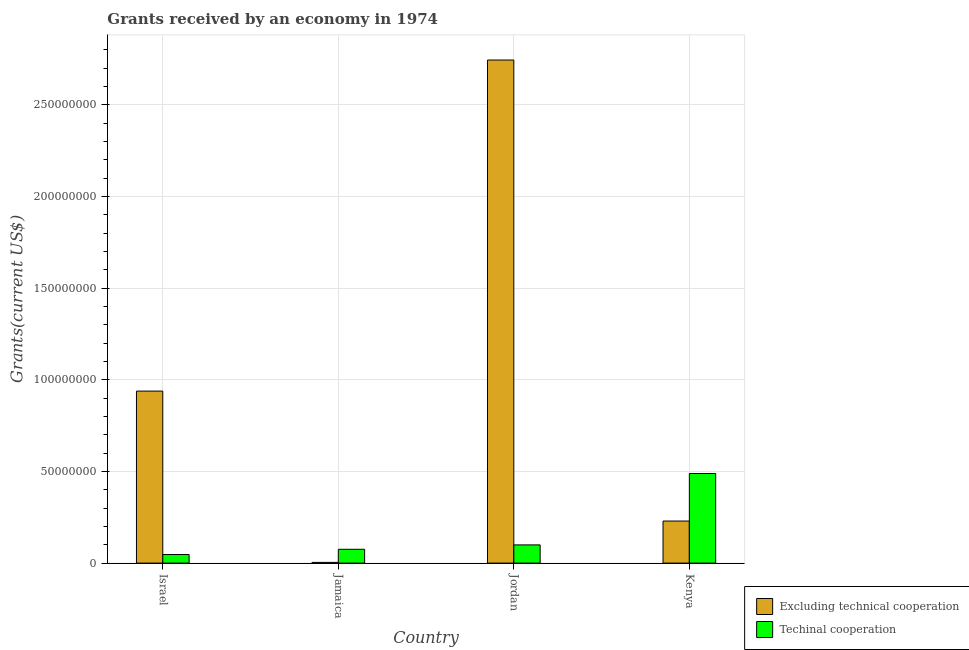How many different coloured bars are there?
Your answer should be compact. 2. How many groups of bars are there?
Your answer should be compact. 4. How many bars are there on the 3rd tick from the left?
Offer a terse response. 2. What is the label of the 2nd group of bars from the left?
Ensure brevity in your answer.  Jamaica. In how many cases, is the number of bars for a given country not equal to the number of legend labels?
Make the answer very short. 0. What is the amount of grants received(excluding technical cooperation) in Israel?
Your answer should be very brief. 9.38e+07. Across all countries, what is the maximum amount of grants received(excluding technical cooperation)?
Provide a succinct answer. 2.74e+08. Across all countries, what is the minimum amount of grants received(including technical cooperation)?
Make the answer very short. 4.68e+06. In which country was the amount of grants received(excluding technical cooperation) maximum?
Your answer should be compact. Jordan. What is the total amount of grants received(including technical cooperation) in the graph?
Your response must be concise. 7.10e+07. What is the difference between the amount of grants received(excluding technical cooperation) in Jamaica and that in Kenya?
Keep it short and to the point. -2.26e+07. What is the difference between the amount of grants received(including technical cooperation) in Israel and the amount of grants received(excluding technical cooperation) in Jordan?
Your answer should be compact. -2.70e+08. What is the average amount of grants received(including technical cooperation) per country?
Your answer should be very brief. 1.78e+07. What is the difference between the amount of grants received(excluding technical cooperation) and amount of grants received(including technical cooperation) in Jordan?
Make the answer very short. 2.64e+08. In how many countries, is the amount of grants received(excluding technical cooperation) greater than 30000000 US$?
Your answer should be compact. 2. What is the ratio of the amount of grants received(including technical cooperation) in Israel to that in Jordan?
Your response must be concise. 0.47. Is the difference between the amount of grants received(excluding technical cooperation) in Israel and Kenya greater than the difference between the amount of grants received(including technical cooperation) in Israel and Kenya?
Keep it short and to the point. Yes. What is the difference between the highest and the second highest amount of grants received(including technical cooperation)?
Your answer should be very brief. 3.90e+07. What is the difference between the highest and the lowest amount of grants received(excluding technical cooperation)?
Provide a short and direct response. 2.74e+08. In how many countries, is the amount of grants received(excluding technical cooperation) greater than the average amount of grants received(excluding technical cooperation) taken over all countries?
Ensure brevity in your answer.  1. Is the sum of the amount of grants received(excluding technical cooperation) in Israel and Kenya greater than the maximum amount of grants received(including technical cooperation) across all countries?
Provide a succinct answer. Yes. What does the 1st bar from the left in Jamaica represents?
Keep it short and to the point. Excluding technical cooperation. What does the 1st bar from the right in Kenya represents?
Offer a terse response. Techinal cooperation. Are all the bars in the graph horizontal?
Provide a succinct answer. No. How many countries are there in the graph?
Ensure brevity in your answer.  4. Are the values on the major ticks of Y-axis written in scientific E-notation?
Provide a short and direct response. No. Where does the legend appear in the graph?
Offer a terse response. Bottom right. How many legend labels are there?
Offer a terse response. 2. How are the legend labels stacked?
Ensure brevity in your answer.  Vertical. What is the title of the graph?
Make the answer very short. Grants received by an economy in 1974. What is the label or title of the Y-axis?
Offer a terse response. Grants(current US$). What is the Grants(current US$) in Excluding technical cooperation in Israel?
Offer a very short reply. 9.38e+07. What is the Grants(current US$) of Techinal cooperation in Israel?
Ensure brevity in your answer.  4.68e+06. What is the Grants(current US$) of Excluding technical cooperation in Jamaica?
Provide a short and direct response. 3.80e+05. What is the Grants(current US$) in Techinal cooperation in Jamaica?
Ensure brevity in your answer.  7.53e+06. What is the Grants(current US$) in Excluding technical cooperation in Jordan?
Provide a succinct answer. 2.74e+08. What is the Grants(current US$) in Techinal cooperation in Jordan?
Ensure brevity in your answer.  9.93e+06. What is the Grants(current US$) in Excluding technical cooperation in Kenya?
Ensure brevity in your answer.  2.29e+07. What is the Grants(current US$) of Techinal cooperation in Kenya?
Make the answer very short. 4.89e+07. Across all countries, what is the maximum Grants(current US$) of Excluding technical cooperation?
Ensure brevity in your answer.  2.74e+08. Across all countries, what is the maximum Grants(current US$) in Techinal cooperation?
Your response must be concise. 4.89e+07. Across all countries, what is the minimum Grants(current US$) in Techinal cooperation?
Ensure brevity in your answer.  4.68e+06. What is the total Grants(current US$) of Excluding technical cooperation in the graph?
Your answer should be very brief. 3.92e+08. What is the total Grants(current US$) in Techinal cooperation in the graph?
Your answer should be compact. 7.10e+07. What is the difference between the Grants(current US$) of Excluding technical cooperation in Israel and that in Jamaica?
Keep it short and to the point. 9.34e+07. What is the difference between the Grants(current US$) in Techinal cooperation in Israel and that in Jamaica?
Make the answer very short. -2.85e+06. What is the difference between the Grants(current US$) in Excluding technical cooperation in Israel and that in Jordan?
Your answer should be very brief. -1.81e+08. What is the difference between the Grants(current US$) in Techinal cooperation in Israel and that in Jordan?
Make the answer very short. -5.25e+06. What is the difference between the Grants(current US$) of Excluding technical cooperation in Israel and that in Kenya?
Give a very brief answer. 7.09e+07. What is the difference between the Grants(current US$) of Techinal cooperation in Israel and that in Kenya?
Ensure brevity in your answer.  -4.42e+07. What is the difference between the Grants(current US$) of Excluding technical cooperation in Jamaica and that in Jordan?
Offer a terse response. -2.74e+08. What is the difference between the Grants(current US$) of Techinal cooperation in Jamaica and that in Jordan?
Offer a terse response. -2.40e+06. What is the difference between the Grants(current US$) in Excluding technical cooperation in Jamaica and that in Kenya?
Offer a very short reply. -2.26e+07. What is the difference between the Grants(current US$) of Techinal cooperation in Jamaica and that in Kenya?
Your response must be concise. -4.14e+07. What is the difference between the Grants(current US$) of Excluding technical cooperation in Jordan and that in Kenya?
Make the answer very short. 2.51e+08. What is the difference between the Grants(current US$) of Techinal cooperation in Jordan and that in Kenya?
Ensure brevity in your answer.  -3.90e+07. What is the difference between the Grants(current US$) of Excluding technical cooperation in Israel and the Grants(current US$) of Techinal cooperation in Jamaica?
Offer a terse response. 8.63e+07. What is the difference between the Grants(current US$) of Excluding technical cooperation in Israel and the Grants(current US$) of Techinal cooperation in Jordan?
Provide a short and direct response. 8.39e+07. What is the difference between the Grants(current US$) of Excluding technical cooperation in Israel and the Grants(current US$) of Techinal cooperation in Kenya?
Provide a short and direct response. 4.50e+07. What is the difference between the Grants(current US$) in Excluding technical cooperation in Jamaica and the Grants(current US$) in Techinal cooperation in Jordan?
Your answer should be very brief. -9.55e+06. What is the difference between the Grants(current US$) of Excluding technical cooperation in Jamaica and the Grants(current US$) of Techinal cooperation in Kenya?
Give a very brief answer. -4.85e+07. What is the difference between the Grants(current US$) of Excluding technical cooperation in Jordan and the Grants(current US$) of Techinal cooperation in Kenya?
Your answer should be very brief. 2.26e+08. What is the average Grants(current US$) of Excluding technical cooperation per country?
Offer a very short reply. 9.79e+07. What is the average Grants(current US$) of Techinal cooperation per country?
Make the answer very short. 1.78e+07. What is the difference between the Grants(current US$) in Excluding technical cooperation and Grants(current US$) in Techinal cooperation in Israel?
Ensure brevity in your answer.  8.92e+07. What is the difference between the Grants(current US$) in Excluding technical cooperation and Grants(current US$) in Techinal cooperation in Jamaica?
Keep it short and to the point. -7.15e+06. What is the difference between the Grants(current US$) of Excluding technical cooperation and Grants(current US$) of Techinal cooperation in Jordan?
Ensure brevity in your answer.  2.64e+08. What is the difference between the Grants(current US$) of Excluding technical cooperation and Grants(current US$) of Techinal cooperation in Kenya?
Offer a very short reply. -2.59e+07. What is the ratio of the Grants(current US$) of Excluding technical cooperation in Israel to that in Jamaica?
Keep it short and to the point. 246.92. What is the ratio of the Grants(current US$) in Techinal cooperation in Israel to that in Jamaica?
Give a very brief answer. 0.62. What is the ratio of the Grants(current US$) in Excluding technical cooperation in Israel to that in Jordan?
Provide a short and direct response. 0.34. What is the ratio of the Grants(current US$) of Techinal cooperation in Israel to that in Jordan?
Your answer should be very brief. 0.47. What is the ratio of the Grants(current US$) of Excluding technical cooperation in Israel to that in Kenya?
Your response must be concise. 4.09. What is the ratio of the Grants(current US$) of Techinal cooperation in Israel to that in Kenya?
Offer a terse response. 0.1. What is the ratio of the Grants(current US$) of Excluding technical cooperation in Jamaica to that in Jordan?
Your answer should be very brief. 0. What is the ratio of the Grants(current US$) in Techinal cooperation in Jamaica to that in Jordan?
Keep it short and to the point. 0.76. What is the ratio of the Grants(current US$) of Excluding technical cooperation in Jamaica to that in Kenya?
Offer a very short reply. 0.02. What is the ratio of the Grants(current US$) in Techinal cooperation in Jamaica to that in Kenya?
Give a very brief answer. 0.15. What is the ratio of the Grants(current US$) of Excluding technical cooperation in Jordan to that in Kenya?
Your answer should be very brief. 11.96. What is the ratio of the Grants(current US$) in Techinal cooperation in Jordan to that in Kenya?
Your answer should be very brief. 0.2. What is the difference between the highest and the second highest Grants(current US$) in Excluding technical cooperation?
Offer a terse response. 1.81e+08. What is the difference between the highest and the second highest Grants(current US$) of Techinal cooperation?
Provide a succinct answer. 3.90e+07. What is the difference between the highest and the lowest Grants(current US$) in Excluding technical cooperation?
Offer a very short reply. 2.74e+08. What is the difference between the highest and the lowest Grants(current US$) in Techinal cooperation?
Offer a terse response. 4.42e+07. 